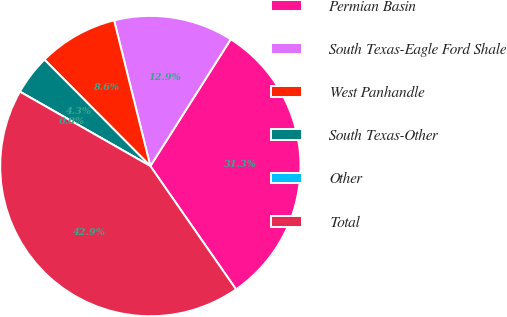<chart> <loc_0><loc_0><loc_500><loc_500><pie_chart><fcel>Permian Basin<fcel>South Texas-Eagle Ford Shale<fcel>West Panhandle<fcel>South Texas-Other<fcel>Other<fcel>Total<nl><fcel>31.34%<fcel>12.87%<fcel>8.58%<fcel>4.29%<fcel>0.0%<fcel>42.91%<nl></chart> 